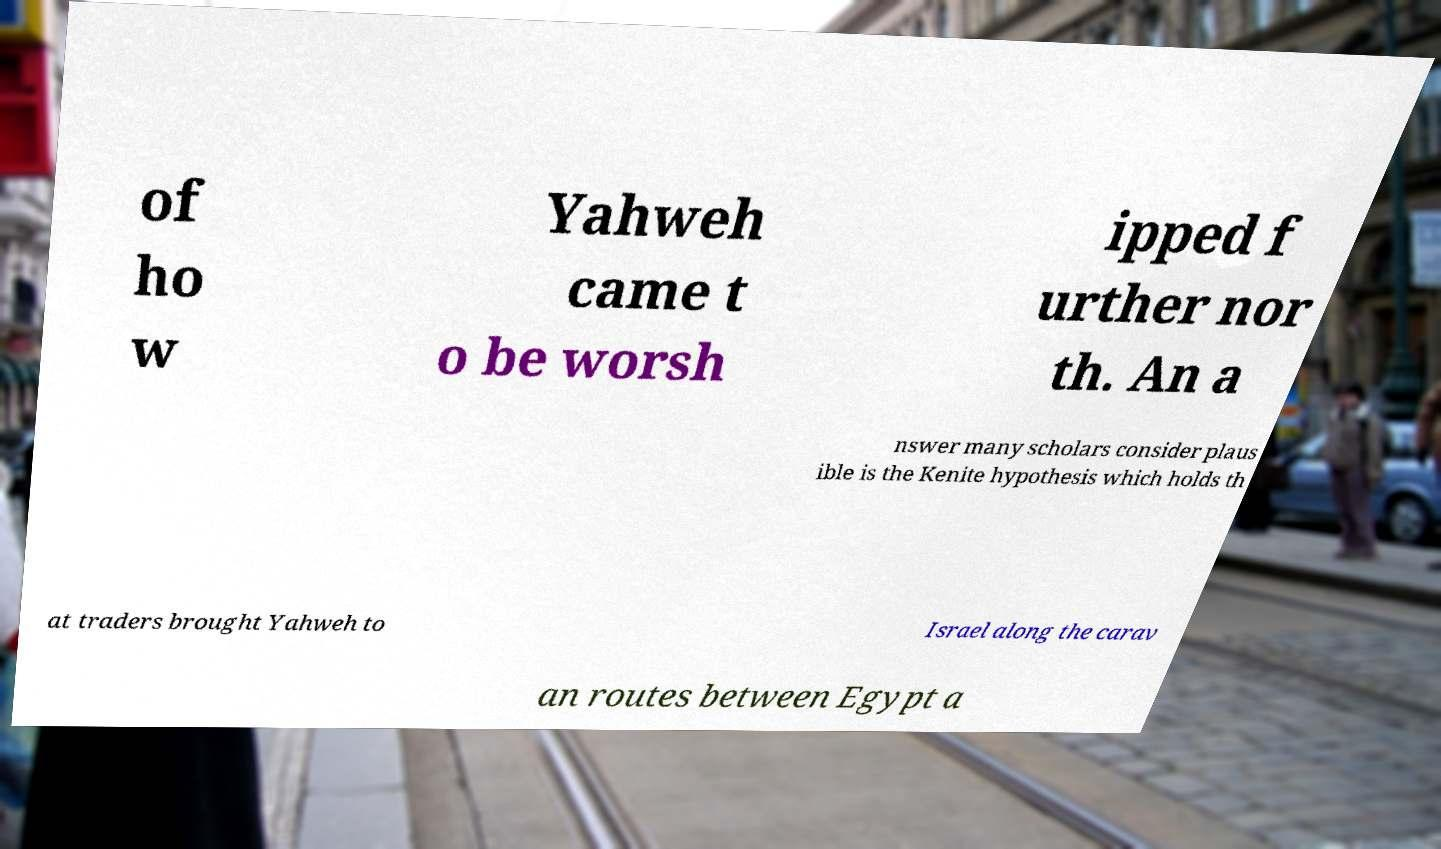What messages or text are displayed in this image? I need them in a readable, typed format. of ho w Yahweh came t o be worsh ipped f urther nor th. An a nswer many scholars consider plaus ible is the Kenite hypothesis which holds th at traders brought Yahweh to Israel along the carav an routes between Egypt a 